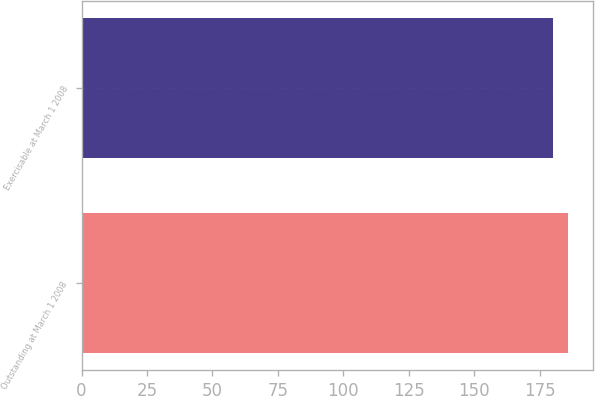Convert chart to OTSL. <chart><loc_0><loc_0><loc_500><loc_500><bar_chart><fcel>Outstanding at March 1 2008<fcel>Exercisable at March 1 2008<nl><fcel>186<fcel>180<nl></chart> 